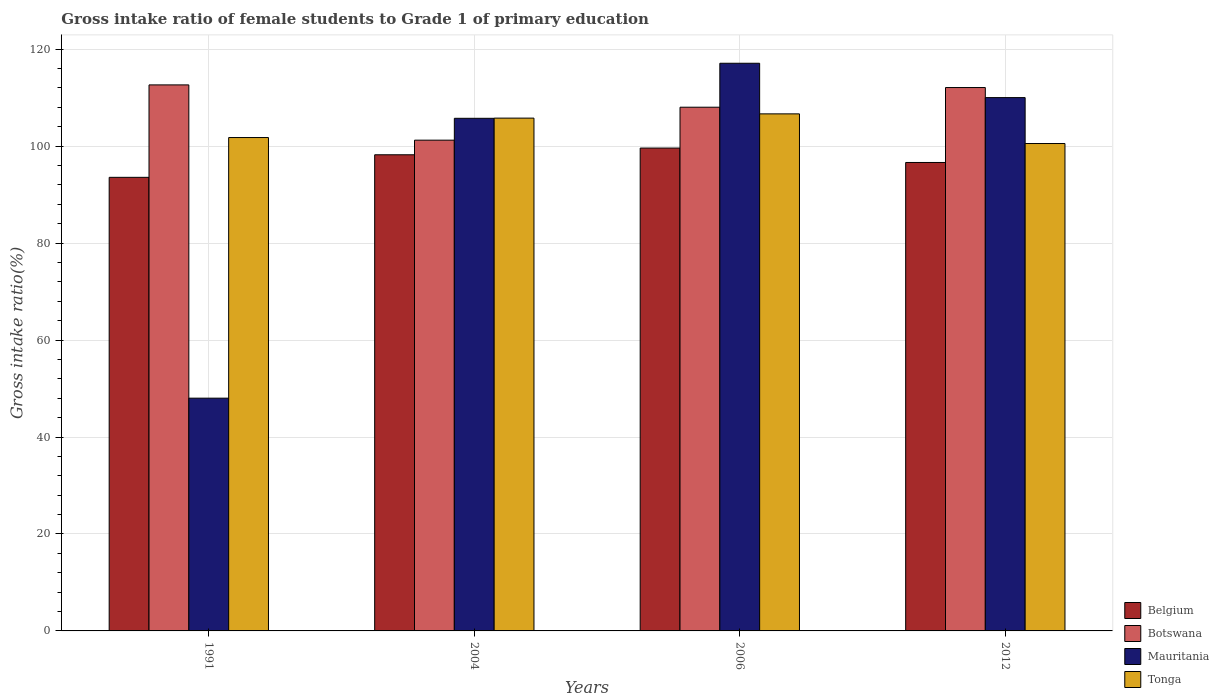How many groups of bars are there?
Your answer should be very brief. 4. How many bars are there on the 4th tick from the right?
Ensure brevity in your answer.  4. What is the label of the 2nd group of bars from the left?
Provide a succinct answer. 2004. What is the gross intake ratio in Mauritania in 2006?
Ensure brevity in your answer.  117.1. Across all years, what is the maximum gross intake ratio in Botswana?
Offer a terse response. 112.64. Across all years, what is the minimum gross intake ratio in Belgium?
Provide a succinct answer. 93.57. In which year was the gross intake ratio in Tonga minimum?
Your answer should be very brief. 2012. What is the total gross intake ratio in Botswana in the graph?
Your answer should be very brief. 434. What is the difference between the gross intake ratio in Tonga in 1991 and that in 2012?
Offer a very short reply. 1.23. What is the difference between the gross intake ratio in Mauritania in 2012 and the gross intake ratio in Belgium in 1991?
Offer a terse response. 16.45. What is the average gross intake ratio in Botswana per year?
Give a very brief answer. 108.5. In the year 2006, what is the difference between the gross intake ratio in Mauritania and gross intake ratio in Belgium?
Give a very brief answer. 17.49. What is the ratio of the gross intake ratio in Botswana in 1991 to that in 2006?
Your answer should be compact. 1.04. What is the difference between the highest and the second highest gross intake ratio in Tonga?
Give a very brief answer. 0.88. What is the difference between the highest and the lowest gross intake ratio in Botswana?
Keep it short and to the point. 11.4. Is the sum of the gross intake ratio in Botswana in 1991 and 2006 greater than the maximum gross intake ratio in Mauritania across all years?
Provide a succinct answer. Yes. What does the 2nd bar from the left in 2012 represents?
Your answer should be compact. Botswana. What does the 2nd bar from the right in 2006 represents?
Ensure brevity in your answer.  Mauritania. Is it the case that in every year, the sum of the gross intake ratio in Botswana and gross intake ratio in Tonga is greater than the gross intake ratio in Belgium?
Your answer should be very brief. Yes. How many years are there in the graph?
Provide a succinct answer. 4. Are the values on the major ticks of Y-axis written in scientific E-notation?
Give a very brief answer. No. How are the legend labels stacked?
Offer a very short reply. Vertical. What is the title of the graph?
Provide a short and direct response. Gross intake ratio of female students to Grade 1 of primary education. Does "Bulgaria" appear as one of the legend labels in the graph?
Your answer should be very brief. No. What is the label or title of the X-axis?
Give a very brief answer. Years. What is the label or title of the Y-axis?
Provide a short and direct response. Gross intake ratio(%). What is the Gross intake ratio(%) of Belgium in 1991?
Provide a succinct answer. 93.57. What is the Gross intake ratio(%) in Botswana in 1991?
Offer a terse response. 112.64. What is the Gross intake ratio(%) of Mauritania in 1991?
Your answer should be compact. 48.01. What is the Gross intake ratio(%) of Tonga in 1991?
Ensure brevity in your answer.  101.78. What is the Gross intake ratio(%) of Belgium in 2004?
Keep it short and to the point. 98.22. What is the Gross intake ratio(%) of Botswana in 2004?
Keep it short and to the point. 101.23. What is the Gross intake ratio(%) of Mauritania in 2004?
Offer a very short reply. 105.74. What is the Gross intake ratio(%) in Tonga in 2004?
Your response must be concise. 105.78. What is the Gross intake ratio(%) of Belgium in 2006?
Ensure brevity in your answer.  99.61. What is the Gross intake ratio(%) of Botswana in 2006?
Your answer should be compact. 108.03. What is the Gross intake ratio(%) in Mauritania in 2006?
Make the answer very short. 117.1. What is the Gross intake ratio(%) in Tonga in 2006?
Make the answer very short. 106.66. What is the Gross intake ratio(%) of Belgium in 2012?
Give a very brief answer. 96.63. What is the Gross intake ratio(%) of Botswana in 2012?
Give a very brief answer. 112.09. What is the Gross intake ratio(%) in Mauritania in 2012?
Provide a succinct answer. 110.02. What is the Gross intake ratio(%) in Tonga in 2012?
Keep it short and to the point. 100.54. Across all years, what is the maximum Gross intake ratio(%) in Belgium?
Your response must be concise. 99.61. Across all years, what is the maximum Gross intake ratio(%) of Botswana?
Offer a terse response. 112.64. Across all years, what is the maximum Gross intake ratio(%) of Mauritania?
Give a very brief answer. 117.1. Across all years, what is the maximum Gross intake ratio(%) in Tonga?
Provide a succinct answer. 106.66. Across all years, what is the minimum Gross intake ratio(%) of Belgium?
Give a very brief answer. 93.57. Across all years, what is the minimum Gross intake ratio(%) in Botswana?
Make the answer very short. 101.23. Across all years, what is the minimum Gross intake ratio(%) of Mauritania?
Your response must be concise. 48.01. Across all years, what is the minimum Gross intake ratio(%) in Tonga?
Make the answer very short. 100.54. What is the total Gross intake ratio(%) of Belgium in the graph?
Offer a very short reply. 388.03. What is the total Gross intake ratio(%) in Botswana in the graph?
Provide a short and direct response. 434. What is the total Gross intake ratio(%) of Mauritania in the graph?
Give a very brief answer. 380.87. What is the total Gross intake ratio(%) in Tonga in the graph?
Provide a succinct answer. 414.76. What is the difference between the Gross intake ratio(%) in Belgium in 1991 and that in 2004?
Make the answer very short. -4.66. What is the difference between the Gross intake ratio(%) of Botswana in 1991 and that in 2004?
Make the answer very short. 11.4. What is the difference between the Gross intake ratio(%) in Mauritania in 1991 and that in 2004?
Give a very brief answer. -57.73. What is the difference between the Gross intake ratio(%) in Tonga in 1991 and that in 2004?
Keep it short and to the point. -4.01. What is the difference between the Gross intake ratio(%) of Belgium in 1991 and that in 2006?
Make the answer very short. -6.04. What is the difference between the Gross intake ratio(%) of Botswana in 1991 and that in 2006?
Offer a terse response. 4.6. What is the difference between the Gross intake ratio(%) in Mauritania in 1991 and that in 2006?
Offer a terse response. -69.09. What is the difference between the Gross intake ratio(%) of Tonga in 1991 and that in 2006?
Make the answer very short. -4.89. What is the difference between the Gross intake ratio(%) in Belgium in 1991 and that in 2012?
Keep it short and to the point. -3.07. What is the difference between the Gross intake ratio(%) of Botswana in 1991 and that in 2012?
Provide a short and direct response. 0.55. What is the difference between the Gross intake ratio(%) of Mauritania in 1991 and that in 2012?
Provide a succinct answer. -62. What is the difference between the Gross intake ratio(%) in Tonga in 1991 and that in 2012?
Keep it short and to the point. 1.23. What is the difference between the Gross intake ratio(%) in Belgium in 2004 and that in 2006?
Offer a terse response. -1.38. What is the difference between the Gross intake ratio(%) in Mauritania in 2004 and that in 2006?
Ensure brevity in your answer.  -11.36. What is the difference between the Gross intake ratio(%) in Tonga in 2004 and that in 2006?
Make the answer very short. -0.88. What is the difference between the Gross intake ratio(%) of Belgium in 2004 and that in 2012?
Keep it short and to the point. 1.59. What is the difference between the Gross intake ratio(%) of Botswana in 2004 and that in 2012?
Make the answer very short. -10.86. What is the difference between the Gross intake ratio(%) of Mauritania in 2004 and that in 2012?
Offer a terse response. -4.27. What is the difference between the Gross intake ratio(%) of Tonga in 2004 and that in 2012?
Your response must be concise. 5.24. What is the difference between the Gross intake ratio(%) of Belgium in 2006 and that in 2012?
Make the answer very short. 2.97. What is the difference between the Gross intake ratio(%) of Botswana in 2006 and that in 2012?
Offer a very short reply. -4.06. What is the difference between the Gross intake ratio(%) of Mauritania in 2006 and that in 2012?
Make the answer very short. 7.08. What is the difference between the Gross intake ratio(%) of Tonga in 2006 and that in 2012?
Your answer should be very brief. 6.12. What is the difference between the Gross intake ratio(%) of Belgium in 1991 and the Gross intake ratio(%) of Botswana in 2004?
Keep it short and to the point. -7.67. What is the difference between the Gross intake ratio(%) in Belgium in 1991 and the Gross intake ratio(%) in Mauritania in 2004?
Make the answer very short. -12.18. What is the difference between the Gross intake ratio(%) in Belgium in 1991 and the Gross intake ratio(%) in Tonga in 2004?
Provide a succinct answer. -12.22. What is the difference between the Gross intake ratio(%) of Botswana in 1991 and the Gross intake ratio(%) of Mauritania in 2004?
Make the answer very short. 6.89. What is the difference between the Gross intake ratio(%) of Botswana in 1991 and the Gross intake ratio(%) of Tonga in 2004?
Your answer should be very brief. 6.85. What is the difference between the Gross intake ratio(%) in Mauritania in 1991 and the Gross intake ratio(%) in Tonga in 2004?
Offer a very short reply. -57.77. What is the difference between the Gross intake ratio(%) in Belgium in 1991 and the Gross intake ratio(%) in Botswana in 2006?
Your response must be concise. -14.47. What is the difference between the Gross intake ratio(%) in Belgium in 1991 and the Gross intake ratio(%) in Mauritania in 2006?
Ensure brevity in your answer.  -23.53. What is the difference between the Gross intake ratio(%) of Belgium in 1991 and the Gross intake ratio(%) of Tonga in 2006?
Provide a succinct answer. -13.09. What is the difference between the Gross intake ratio(%) of Botswana in 1991 and the Gross intake ratio(%) of Mauritania in 2006?
Your answer should be very brief. -4.46. What is the difference between the Gross intake ratio(%) in Botswana in 1991 and the Gross intake ratio(%) in Tonga in 2006?
Offer a very short reply. 5.98. What is the difference between the Gross intake ratio(%) in Mauritania in 1991 and the Gross intake ratio(%) in Tonga in 2006?
Provide a short and direct response. -58.65. What is the difference between the Gross intake ratio(%) in Belgium in 1991 and the Gross intake ratio(%) in Botswana in 2012?
Ensure brevity in your answer.  -18.52. What is the difference between the Gross intake ratio(%) in Belgium in 1991 and the Gross intake ratio(%) in Mauritania in 2012?
Offer a terse response. -16.45. What is the difference between the Gross intake ratio(%) in Belgium in 1991 and the Gross intake ratio(%) in Tonga in 2012?
Provide a succinct answer. -6.98. What is the difference between the Gross intake ratio(%) of Botswana in 1991 and the Gross intake ratio(%) of Mauritania in 2012?
Your answer should be very brief. 2.62. What is the difference between the Gross intake ratio(%) of Botswana in 1991 and the Gross intake ratio(%) of Tonga in 2012?
Your response must be concise. 12.09. What is the difference between the Gross intake ratio(%) of Mauritania in 1991 and the Gross intake ratio(%) of Tonga in 2012?
Your answer should be compact. -52.53. What is the difference between the Gross intake ratio(%) of Belgium in 2004 and the Gross intake ratio(%) of Botswana in 2006?
Your response must be concise. -9.81. What is the difference between the Gross intake ratio(%) in Belgium in 2004 and the Gross intake ratio(%) in Mauritania in 2006?
Offer a very short reply. -18.88. What is the difference between the Gross intake ratio(%) in Belgium in 2004 and the Gross intake ratio(%) in Tonga in 2006?
Offer a very short reply. -8.44. What is the difference between the Gross intake ratio(%) of Botswana in 2004 and the Gross intake ratio(%) of Mauritania in 2006?
Provide a short and direct response. -15.87. What is the difference between the Gross intake ratio(%) of Botswana in 2004 and the Gross intake ratio(%) of Tonga in 2006?
Keep it short and to the point. -5.43. What is the difference between the Gross intake ratio(%) in Mauritania in 2004 and the Gross intake ratio(%) in Tonga in 2006?
Give a very brief answer. -0.92. What is the difference between the Gross intake ratio(%) in Belgium in 2004 and the Gross intake ratio(%) in Botswana in 2012?
Your answer should be very brief. -13.87. What is the difference between the Gross intake ratio(%) in Belgium in 2004 and the Gross intake ratio(%) in Mauritania in 2012?
Keep it short and to the point. -11.79. What is the difference between the Gross intake ratio(%) in Belgium in 2004 and the Gross intake ratio(%) in Tonga in 2012?
Give a very brief answer. -2.32. What is the difference between the Gross intake ratio(%) of Botswana in 2004 and the Gross intake ratio(%) of Mauritania in 2012?
Your answer should be compact. -8.78. What is the difference between the Gross intake ratio(%) of Botswana in 2004 and the Gross intake ratio(%) of Tonga in 2012?
Ensure brevity in your answer.  0.69. What is the difference between the Gross intake ratio(%) of Mauritania in 2004 and the Gross intake ratio(%) of Tonga in 2012?
Keep it short and to the point. 5.2. What is the difference between the Gross intake ratio(%) of Belgium in 2006 and the Gross intake ratio(%) of Botswana in 2012?
Your response must be concise. -12.48. What is the difference between the Gross intake ratio(%) of Belgium in 2006 and the Gross intake ratio(%) of Mauritania in 2012?
Provide a short and direct response. -10.41. What is the difference between the Gross intake ratio(%) of Belgium in 2006 and the Gross intake ratio(%) of Tonga in 2012?
Make the answer very short. -0.94. What is the difference between the Gross intake ratio(%) in Botswana in 2006 and the Gross intake ratio(%) in Mauritania in 2012?
Provide a short and direct response. -1.98. What is the difference between the Gross intake ratio(%) in Botswana in 2006 and the Gross intake ratio(%) in Tonga in 2012?
Your answer should be very brief. 7.49. What is the difference between the Gross intake ratio(%) in Mauritania in 2006 and the Gross intake ratio(%) in Tonga in 2012?
Offer a very short reply. 16.56. What is the average Gross intake ratio(%) in Belgium per year?
Give a very brief answer. 97.01. What is the average Gross intake ratio(%) in Botswana per year?
Provide a succinct answer. 108.5. What is the average Gross intake ratio(%) of Mauritania per year?
Provide a short and direct response. 95.22. What is the average Gross intake ratio(%) of Tonga per year?
Offer a very short reply. 103.69. In the year 1991, what is the difference between the Gross intake ratio(%) in Belgium and Gross intake ratio(%) in Botswana?
Provide a succinct answer. -19.07. In the year 1991, what is the difference between the Gross intake ratio(%) of Belgium and Gross intake ratio(%) of Mauritania?
Your answer should be very brief. 45.55. In the year 1991, what is the difference between the Gross intake ratio(%) in Belgium and Gross intake ratio(%) in Tonga?
Offer a very short reply. -8.21. In the year 1991, what is the difference between the Gross intake ratio(%) of Botswana and Gross intake ratio(%) of Mauritania?
Provide a succinct answer. 64.62. In the year 1991, what is the difference between the Gross intake ratio(%) of Botswana and Gross intake ratio(%) of Tonga?
Ensure brevity in your answer.  10.86. In the year 1991, what is the difference between the Gross intake ratio(%) in Mauritania and Gross intake ratio(%) in Tonga?
Your response must be concise. -53.76. In the year 2004, what is the difference between the Gross intake ratio(%) of Belgium and Gross intake ratio(%) of Botswana?
Your answer should be very brief. -3.01. In the year 2004, what is the difference between the Gross intake ratio(%) of Belgium and Gross intake ratio(%) of Mauritania?
Give a very brief answer. -7.52. In the year 2004, what is the difference between the Gross intake ratio(%) in Belgium and Gross intake ratio(%) in Tonga?
Provide a short and direct response. -7.56. In the year 2004, what is the difference between the Gross intake ratio(%) in Botswana and Gross intake ratio(%) in Mauritania?
Ensure brevity in your answer.  -4.51. In the year 2004, what is the difference between the Gross intake ratio(%) in Botswana and Gross intake ratio(%) in Tonga?
Your response must be concise. -4.55. In the year 2004, what is the difference between the Gross intake ratio(%) in Mauritania and Gross intake ratio(%) in Tonga?
Offer a terse response. -0.04. In the year 2006, what is the difference between the Gross intake ratio(%) in Belgium and Gross intake ratio(%) in Botswana?
Your response must be concise. -8.43. In the year 2006, what is the difference between the Gross intake ratio(%) of Belgium and Gross intake ratio(%) of Mauritania?
Your answer should be very brief. -17.49. In the year 2006, what is the difference between the Gross intake ratio(%) of Belgium and Gross intake ratio(%) of Tonga?
Ensure brevity in your answer.  -7.05. In the year 2006, what is the difference between the Gross intake ratio(%) in Botswana and Gross intake ratio(%) in Mauritania?
Provide a succinct answer. -9.07. In the year 2006, what is the difference between the Gross intake ratio(%) in Botswana and Gross intake ratio(%) in Tonga?
Offer a terse response. 1.37. In the year 2006, what is the difference between the Gross intake ratio(%) of Mauritania and Gross intake ratio(%) of Tonga?
Give a very brief answer. 10.44. In the year 2012, what is the difference between the Gross intake ratio(%) in Belgium and Gross intake ratio(%) in Botswana?
Offer a very short reply. -15.46. In the year 2012, what is the difference between the Gross intake ratio(%) in Belgium and Gross intake ratio(%) in Mauritania?
Keep it short and to the point. -13.38. In the year 2012, what is the difference between the Gross intake ratio(%) of Belgium and Gross intake ratio(%) of Tonga?
Keep it short and to the point. -3.91. In the year 2012, what is the difference between the Gross intake ratio(%) of Botswana and Gross intake ratio(%) of Mauritania?
Provide a short and direct response. 2.08. In the year 2012, what is the difference between the Gross intake ratio(%) of Botswana and Gross intake ratio(%) of Tonga?
Make the answer very short. 11.55. In the year 2012, what is the difference between the Gross intake ratio(%) in Mauritania and Gross intake ratio(%) in Tonga?
Provide a short and direct response. 9.47. What is the ratio of the Gross intake ratio(%) in Belgium in 1991 to that in 2004?
Offer a terse response. 0.95. What is the ratio of the Gross intake ratio(%) of Botswana in 1991 to that in 2004?
Offer a terse response. 1.11. What is the ratio of the Gross intake ratio(%) in Mauritania in 1991 to that in 2004?
Your response must be concise. 0.45. What is the ratio of the Gross intake ratio(%) of Tonga in 1991 to that in 2004?
Give a very brief answer. 0.96. What is the ratio of the Gross intake ratio(%) in Belgium in 1991 to that in 2006?
Your answer should be very brief. 0.94. What is the ratio of the Gross intake ratio(%) of Botswana in 1991 to that in 2006?
Your answer should be compact. 1.04. What is the ratio of the Gross intake ratio(%) in Mauritania in 1991 to that in 2006?
Provide a short and direct response. 0.41. What is the ratio of the Gross intake ratio(%) in Tonga in 1991 to that in 2006?
Provide a succinct answer. 0.95. What is the ratio of the Gross intake ratio(%) in Belgium in 1991 to that in 2012?
Make the answer very short. 0.97. What is the ratio of the Gross intake ratio(%) in Botswana in 1991 to that in 2012?
Make the answer very short. 1. What is the ratio of the Gross intake ratio(%) in Mauritania in 1991 to that in 2012?
Ensure brevity in your answer.  0.44. What is the ratio of the Gross intake ratio(%) in Tonga in 1991 to that in 2012?
Keep it short and to the point. 1.01. What is the ratio of the Gross intake ratio(%) of Belgium in 2004 to that in 2006?
Make the answer very short. 0.99. What is the ratio of the Gross intake ratio(%) of Botswana in 2004 to that in 2006?
Keep it short and to the point. 0.94. What is the ratio of the Gross intake ratio(%) in Mauritania in 2004 to that in 2006?
Your answer should be compact. 0.9. What is the ratio of the Gross intake ratio(%) in Tonga in 2004 to that in 2006?
Your answer should be very brief. 0.99. What is the ratio of the Gross intake ratio(%) of Belgium in 2004 to that in 2012?
Provide a short and direct response. 1.02. What is the ratio of the Gross intake ratio(%) of Botswana in 2004 to that in 2012?
Your answer should be very brief. 0.9. What is the ratio of the Gross intake ratio(%) in Mauritania in 2004 to that in 2012?
Make the answer very short. 0.96. What is the ratio of the Gross intake ratio(%) of Tonga in 2004 to that in 2012?
Make the answer very short. 1.05. What is the ratio of the Gross intake ratio(%) in Belgium in 2006 to that in 2012?
Your answer should be compact. 1.03. What is the ratio of the Gross intake ratio(%) of Botswana in 2006 to that in 2012?
Your answer should be very brief. 0.96. What is the ratio of the Gross intake ratio(%) of Mauritania in 2006 to that in 2012?
Make the answer very short. 1.06. What is the ratio of the Gross intake ratio(%) in Tonga in 2006 to that in 2012?
Give a very brief answer. 1.06. What is the difference between the highest and the second highest Gross intake ratio(%) in Belgium?
Ensure brevity in your answer.  1.38. What is the difference between the highest and the second highest Gross intake ratio(%) in Botswana?
Make the answer very short. 0.55. What is the difference between the highest and the second highest Gross intake ratio(%) in Mauritania?
Give a very brief answer. 7.08. What is the difference between the highest and the second highest Gross intake ratio(%) of Tonga?
Ensure brevity in your answer.  0.88. What is the difference between the highest and the lowest Gross intake ratio(%) of Belgium?
Make the answer very short. 6.04. What is the difference between the highest and the lowest Gross intake ratio(%) in Botswana?
Give a very brief answer. 11.4. What is the difference between the highest and the lowest Gross intake ratio(%) of Mauritania?
Offer a terse response. 69.09. What is the difference between the highest and the lowest Gross intake ratio(%) of Tonga?
Your answer should be very brief. 6.12. 